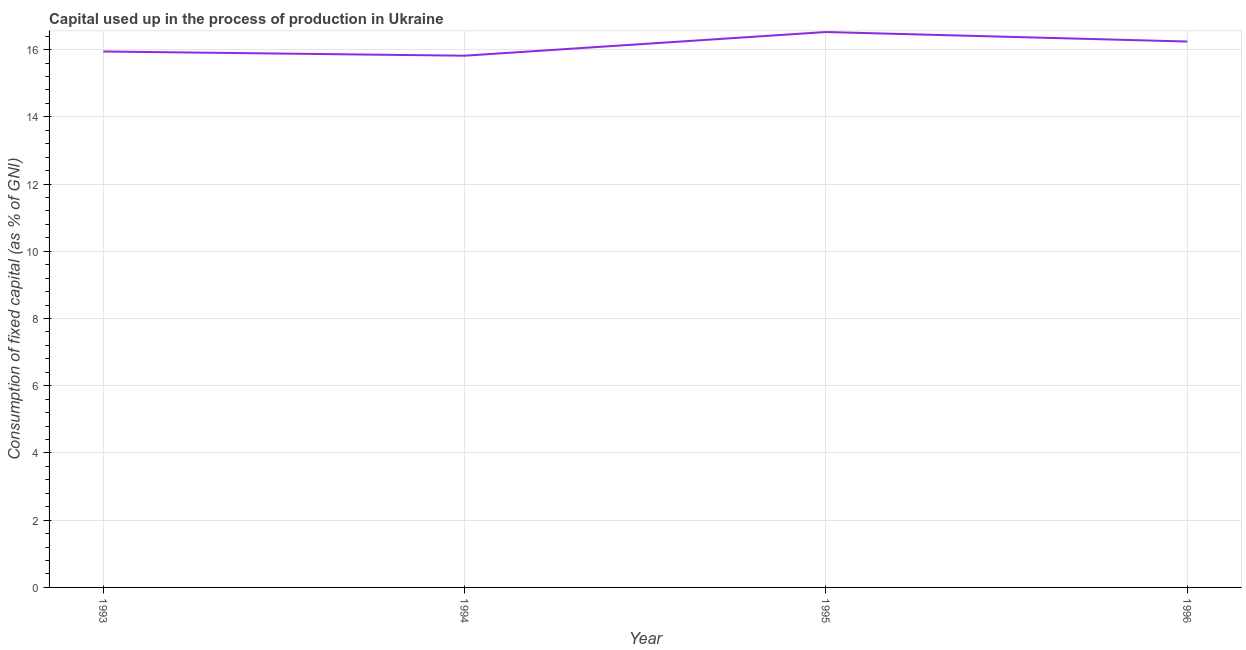What is the consumption of fixed capital in 1994?
Offer a terse response. 15.82. Across all years, what is the maximum consumption of fixed capital?
Provide a succinct answer. 16.52. Across all years, what is the minimum consumption of fixed capital?
Provide a short and direct response. 15.82. In which year was the consumption of fixed capital maximum?
Your answer should be compact. 1995. What is the sum of the consumption of fixed capital?
Give a very brief answer. 64.53. What is the difference between the consumption of fixed capital in 1994 and 1996?
Your answer should be compact. -0.42. What is the average consumption of fixed capital per year?
Your answer should be very brief. 16.13. What is the median consumption of fixed capital?
Give a very brief answer. 16.09. What is the ratio of the consumption of fixed capital in 1994 to that in 1995?
Provide a succinct answer. 0.96. Is the consumption of fixed capital in 1994 less than that in 1995?
Provide a succinct answer. Yes. What is the difference between the highest and the second highest consumption of fixed capital?
Your answer should be very brief. 0.28. Is the sum of the consumption of fixed capital in 1995 and 1996 greater than the maximum consumption of fixed capital across all years?
Offer a very short reply. Yes. What is the difference between the highest and the lowest consumption of fixed capital?
Offer a terse response. 0.71. In how many years, is the consumption of fixed capital greater than the average consumption of fixed capital taken over all years?
Your answer should be very brief. 2. What is the difference between two consecutive major ticks on the Y-axis?
Give a very brief answer. 2. What is the title of the graph?
Offer a terse response. Capital used up in the process of production in Ukraine. What is the label or title of the X-axis?
Make the answer very short. Year. What is the label or title of the Y-axis?
Your response must be concise. Consumption of fixed capital (as % of GNI). What is the Consumption of fixed capital (as % of GNI) in 1993?
Your response must be concise. 15.94. What is the Consumption of fixed capital (as % of GNI) in 1994?
Keep it short and to the point. 15.82. What is the Consumption of fixed capital (as % of GNI) in 1995?
Your answer should be compact. 16.52. What is the Consumption of fixed capital (as % of GNI) in 1996?
Provide a short and direct response. 16.24. What is the difference between the Consumption of fixed capital (as % of GNI) in 1993 and 1994?
Keep it short and to the point. 0.13. What is the difference between the Consumption of fixed capital (as % of GNI) in 1993 and 1995?
Your answer should be compact. -0.58. What is the difference between the Consumption of fixed capital (as % of GNI) in 1993 and 1996?
Give a very brief answer. -0.3. What is the difference between the Consumption of fixed capital (as % of GNI) in 1994 and 1995?
Provide a succinct answer. -0.71. What is the difference between the Consumption of fixed capital (as % of GNI) in 1994 and 1996?
Provide a succinct answer. -0.42. What is the difference between the Consumption of fixed capital (as % of GNI) in 1995 and 1996?
Offer a terse response. 0.28. What is the ratio of the Consumption of fixed capital (as % of GNI) in 1993 to that in 1995?
Offer a terse response. 0.96. What is the ratio of the Consumption of fixed capital (as % of GNI) in 1993 to that in 1996?
Provide a short and direct response. 0.98. What is the ratio of the Consumption of fixed capital (as % of GNI) in 1994 to that in 1995?
Offer a terse response. 0.96. What is the ratio of the Consumption of fixed capital (as % of GNI) in 1995 to that in 1996?
Keep it short and to the point. 1.02. 